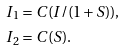<formula> <loc_0><loc_0><loc_500><loc_500>I _ { 1 } & = C ( I / ( 1 + S ) ) , \\ I _ { 2 } & = C ( S ) .</formula> 